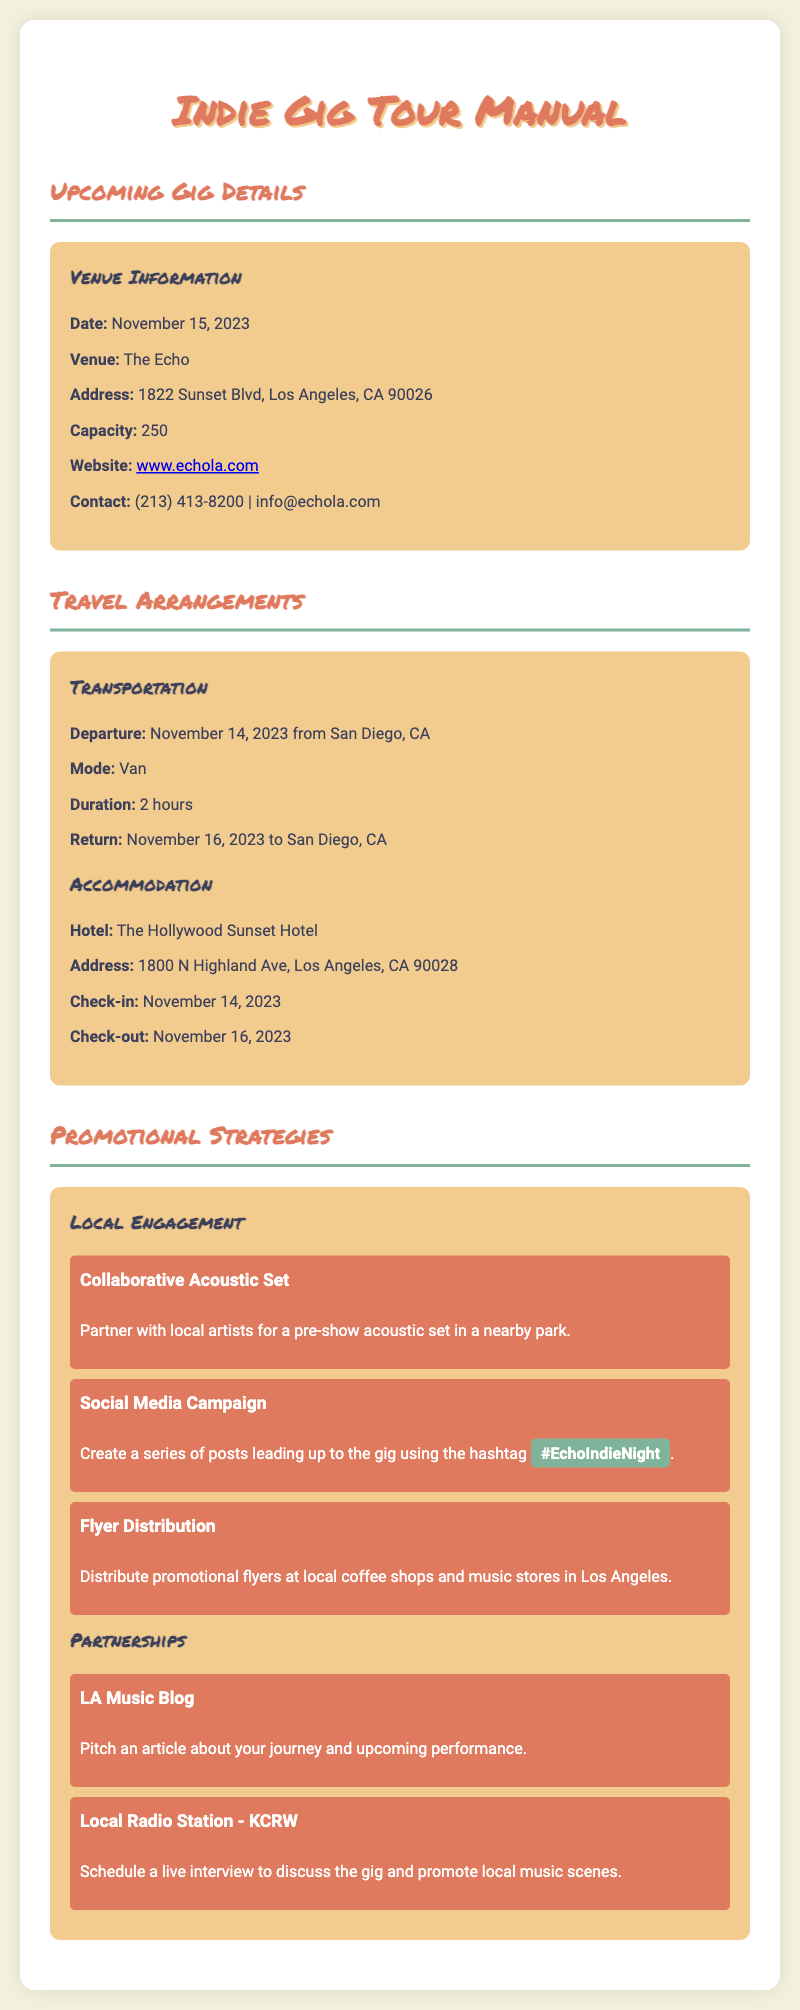what is the date of the gig? The date of the gig is specifically mentioned in the venue information section of the document.
Answer: November 15, 2023 what is the venue name? The venue name is provided in the venue information section of the document.
Answer: The Echo how many people can the venue accommodate? The capacity of the venue is listed clearly in the document.
Answer: 250 what is the mode of transportation to the gig? The mode of transportation is detailed under the travel arrangements section of the document.
Answer: Van what is the address of the hotel? The hotel's address is included in the accommodation section of the travel arrangements.
Answer: 1800 N Highland Ave, Los Angeles, CA 90028 which local radio station is mentioned for a live interview? This information is found in the partnerships section under promotional strategies in the document.
Answer: KCRW what promotional campaign is suggested using a specific hashtag? The specific social media campaign is outlined in the promotional strategies section with a direct reference to a hashtag.
Answer: #EchoIndieNight where should flyers be distributed? The document specifies where promotional flyers should be distributed in the local engagement section of promotional strategies.
Answer: Local coffee shops and music stores in Los Angeles what date is the check-out from the hotel? The check-out date is stated clearly in the accommodation section of the travel arrangements.
Answer: November 16, 2023 